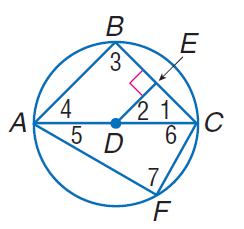Answer the mathemtical geometry problem and directly provide the correct option letter.
Question: In \odot D, D E \cong E C, m C F = 60, and D E \perp E C. Find m \angle 4.
Choices: A: 30 B: 45 C: 60 D: 90 B 